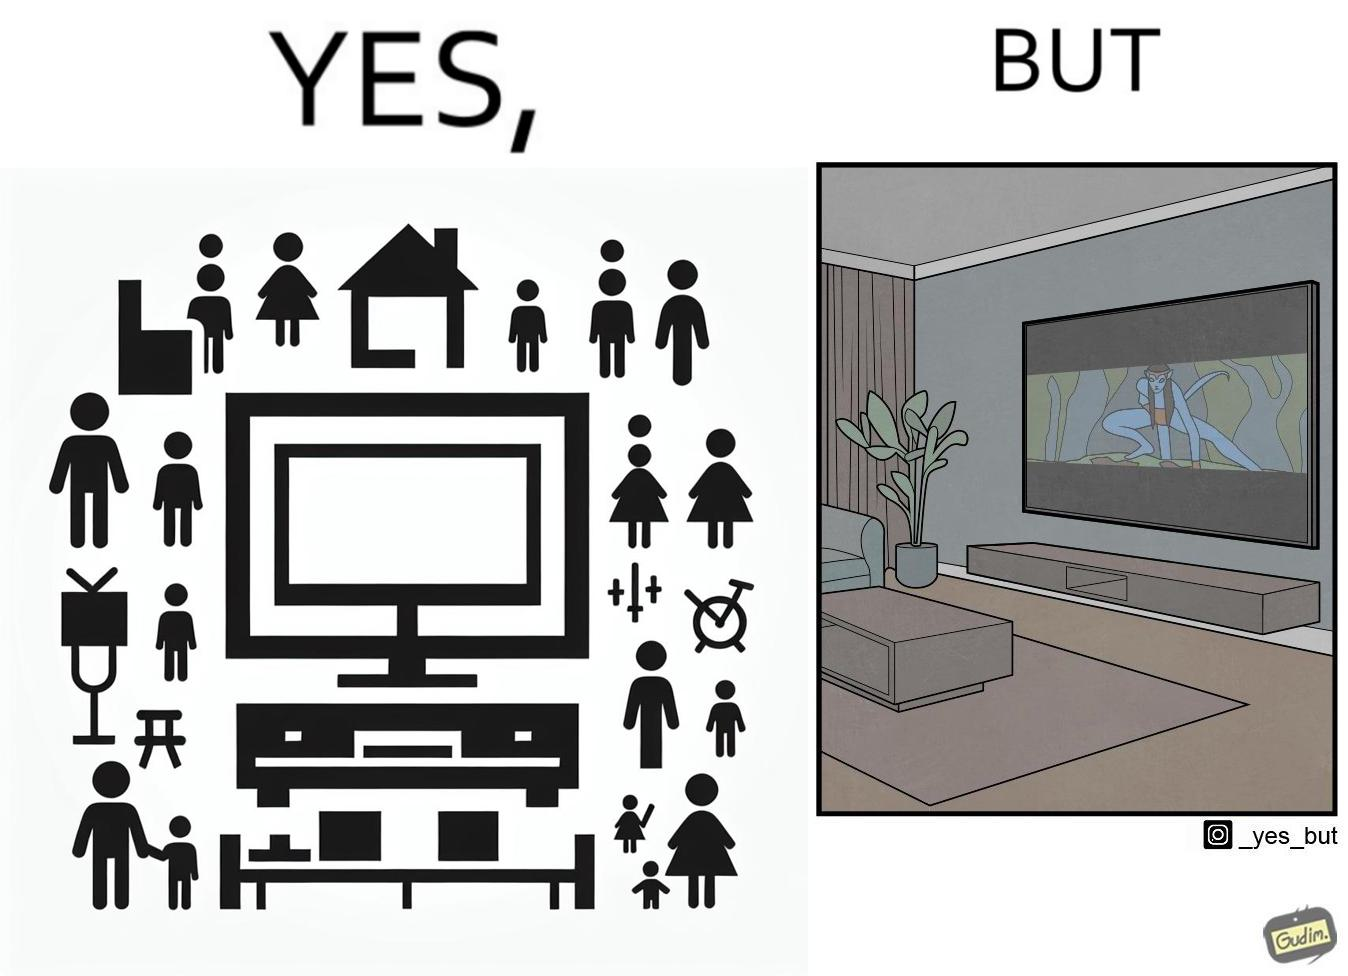Is there satirical content in this image? Yes, this image is satirical. 